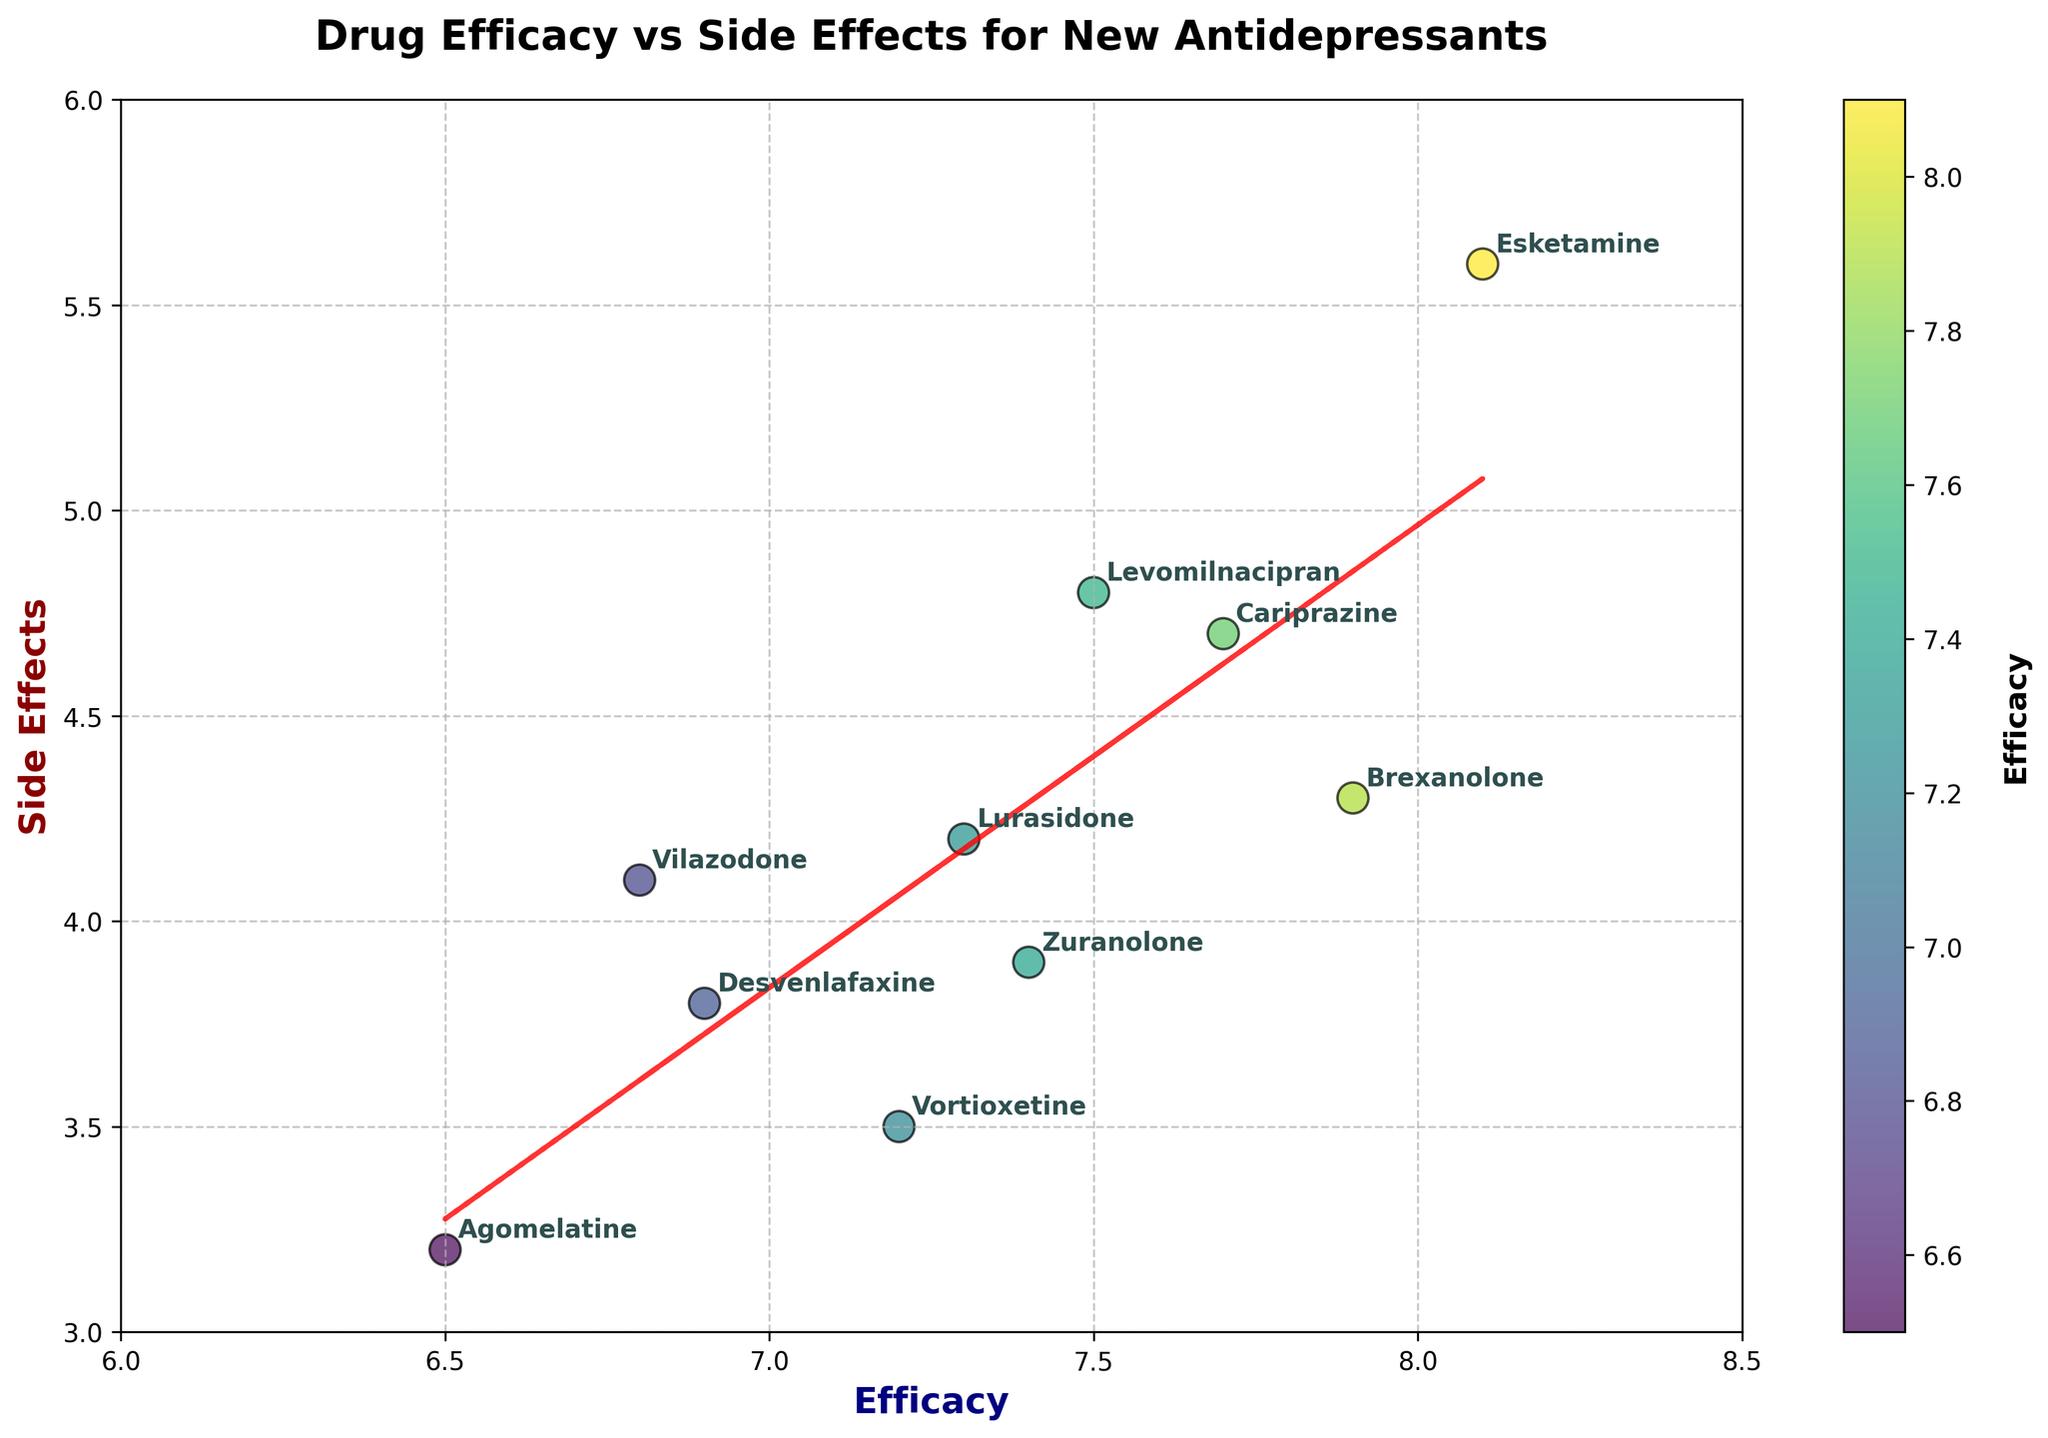What is the title of the plot? The title is typically found at the top of most figures and is designed to summarize the content of the plot. In this case, it helps the viewer understand that the figure concerns both drug efficacy and side effects for new antidepressants.
Answer: Drug Efficacy vs Side Effects for New Antidepressants How many drugs are represented in the figure? By counting the distinct points labeled with drug names on the plot, you can determine the total number of drugs represented.
Answer: 10 What drug has the highest efficacy score? By looking at the efficacy axis (x-axis), the drug with the highest value on the x-axis is Esketamine.
Answer: Esketamine Which drug has the lowest side effects? By examining the side effects axis (y-axis), the drug with the lowest value on the y-axis is Agomelatine.
Answer: Agomelatine What is the relationship between Lurasidone and Vilazodone in terms of side effects and efficacy? First, locate Lurasidone and Vilazodone on the plot. Notice their positions on the axes to compare both side effects and efficacy. Lurasidone has higher efficacy and slightly lower side effects compared to Vilazodone.
Answer: Lurasidone has higher efficacy and lower side effects Is there a trend between efficacy and side effects in the plot? To identify a trend, look at the red dashed trend line fitted through the scatter points. This line helps infer the general relationship between the two variables. The trend line shows that as efficacy increases, side effects tend to increase as well.
Answer: Yes, side effects tend to increase as efficacy increases Which drug is closest to Brexanolone in terms of efficacy and side effects? Find Brexanolone on the plot and identify the neighboring point. Zuranolone is closest to it, as it has similar efficacy and side effects values that are near Brexanolone’s point.
Answer: Zuranolone What are the average efficacy and side effects of all the drugs? Calculate the average efficacy by summing all the efficacy scores and dividing by the number of drugs. Do the same for side effects. (7.2+6.8+7.5+8.1+7.9+7.4+6.5+7.7+7.3+6.9)/10 = 7.33, (3.5+4.1+4.8+5.6+4.3+3.9+3.2+4.7+4.2+3.8)/10 = 4.21.
Answer: Efficacy: 7.33, Side Effects: 4.21 Which drugs have a side effects score greater than 4.5? Identify all the points that are above the value 4.5 on the y-axis. These drugs are Levomilnacipran, Esketamine, and Cariprazine.
Answer: Levomilnacipran, Esketamine, Cariprazine 